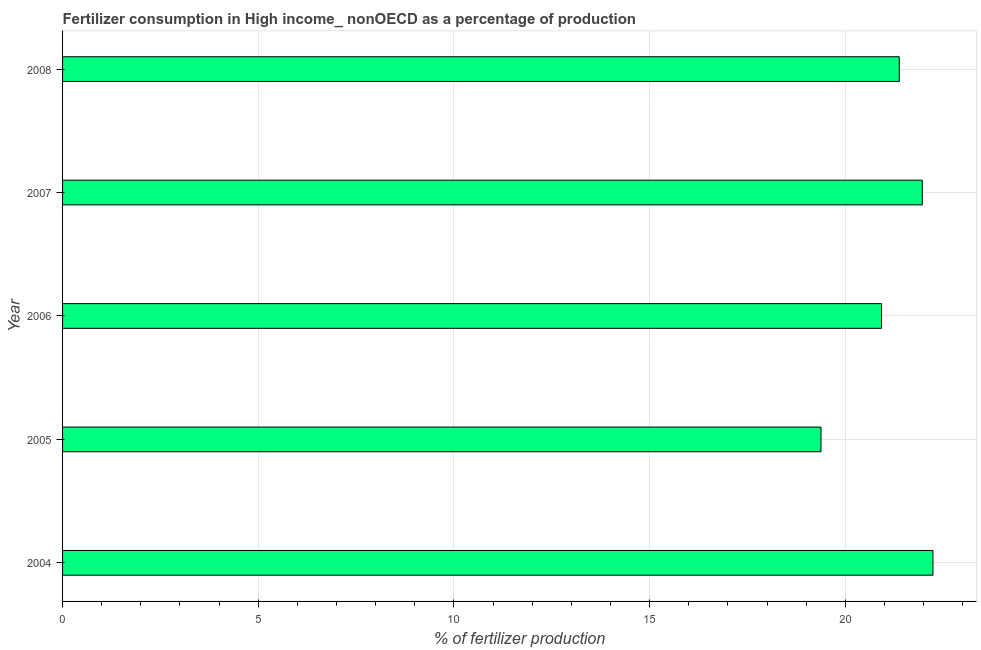What is the title of the graph?
Provide a succinct answer. Fertilizer consumption in High income_ nonOECD as a percentage of production. What is the label or title of the X-axis?
Provide a succinct answer. % of fertilizer production. What is the label or title of the Y-axis?
Make the answer very short. Year. What is the amount of fertilizer consumption in 2007?
Your response must be concise. 21.97. Across all years, what is the maximum amount of fertilizer consumption?
Offer a terse response. 22.24. Across all years, what is the minimum amount of fertilizer consumption?
Offer a terse response. 19.38. In which year was the amount of fertilizer consumption minimum?
Provide a succinct answer. 2005. What is the sum of the amount of fertilizer consumption?
Offer a terse response. 105.89. What is the difference between the amount of fertilizer consumption in 2004 and 2007?
Offer a very short reply. 0.27. What is the average amount of fertilizer consumption per year?
Provide a short and direct response. 21.18. What is the median amount of fertilizer consumption?
Offer a very short reply. 21.38. In how many years, is the amount of fertilizer consumption greater than 2 %?
Keep it short and to the point. 5. Do a majority of the years between 2008 and 2005 (inclusive) have amount of fertilizer consumption greater than 2 %?
Provide a short and direct response. Yes. What is the ratio of the amount of fertilizer consumption in 2007 to that in 2008?
Give a very brief answer. 1.03. Is the amount of fertilizer consumption in 2005 less than that in 2007?
Keep it short and to the point. Yes. Is the difference between the amount of fertilizer consumption in 2005 and 2007 greater than the difference between any two years?
Ensure brevity in your answer.  No. What is the difference between the highest and the second highest amount of fertilizer consumption?
Provide a short and direct response. 0.27. Is the sum of the amount of fertilizer consumption in 2004 and 2007 greater than the maximum amount of fertilizer consumption across all years?
Offer a terse response. Yes. What is the difference between the highest and the lowest amount of fertilizer consumption?
Offer a terse response. 2.86. How many bars are there?
Give a very brief answer. 5. Are all the bars in the graph horizontal?
Keep it short and to the point. Yes. What is the % of fertilizer production in 2004?
Give a very brief answer. 22.24. What is the % of fertilizer production of 2005?
Provide a short and direct response. 19.38. What is the % of fertilizer production of 2006?
Provide a succinct answer. 20.93. What is the % of fertilizer production in 2007?
Offer a terse response. 21.97. What is the % of fertilizer production in 2008?
Make the answer very short. 21.38. What is the difference between the % of fertilizer production in 2004 and 2005?
Provide a short and direct response. 2.86. What is the difference between the % of fertilizer production in 2004 and 2006?
Keep it short and to the point. 1.31. What is the difference between the % of fertilizer production in 2004 and 2007?
Provide a short and direct response. 0.27. What is the difference between the % of fertilizer production in 2004 and 2008?
Ensure brevity in your answer.  0.86. What is the difference between the % of fertilizer production in 2005 and 2006?
Your response must be concise. -1.55. What is the difference between the % of fertilizer production in 2005 and 2007?
Your response must be concise. -2.59. What is the difference between the % of fertilizer production in 2005 and 2008?
Make the answer very short. -2. What is the difference between the % of fertilizer production in 2006 and 2007?
Ensure brevity in your answer.  -1.04. What is the difference between the % of fertilizer production in 2006 and 2008?
Give a very brief answer. -0.45. What is the difference between the % of fertilizer production in 2007 and 2008?
Offer a very short reply. 0.59. What is the ratio of the % of fertilizer production in 2004 to that in 2005?
Keep it short and to the point. 1.15. What is the ratio of the % of fertilizer production in 2004 to that in 2006?
Offer a terse response. 1.06. What is the ratio of the % of fertilizer production in 2004 to that in 2007?
Give a very brief answer. 1.01. What is the ratio of the % of fertilizer production in 2005 to that in 2006?
Provide a succinct answer. 0.93. What is the ratio of the % of fertilizer production in 2005 to that in 2007?
Your answer should be compact. 0.88. What is the ratio of the % of fertilizer production in 2005 to that in 2008?
Offer a very short reply. 0.91. What is the ratio of the % of fertilizer production in 2006 to that in 2007?
Your answer should be very brief. 0.95. What is the ratio of the % of fertilizer production in 2007 to that in 2008?
Offer a terse response. 1.03. 